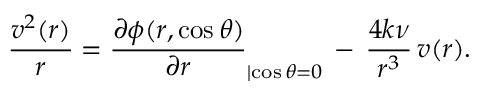Convert formula to latex. <formula><loc_0><loc_0><loc_500><loc_500>\frac { v ^ { 2 } ( r ) } { r } = \frac { \partial \phi ( r , \cos \theta ) } { \partial r } _ { | { \cos \theta = 0 } } \, - \, \frac { 4 k \nu } { r ^ { 3 } } \, v ( r ) .</formula> 